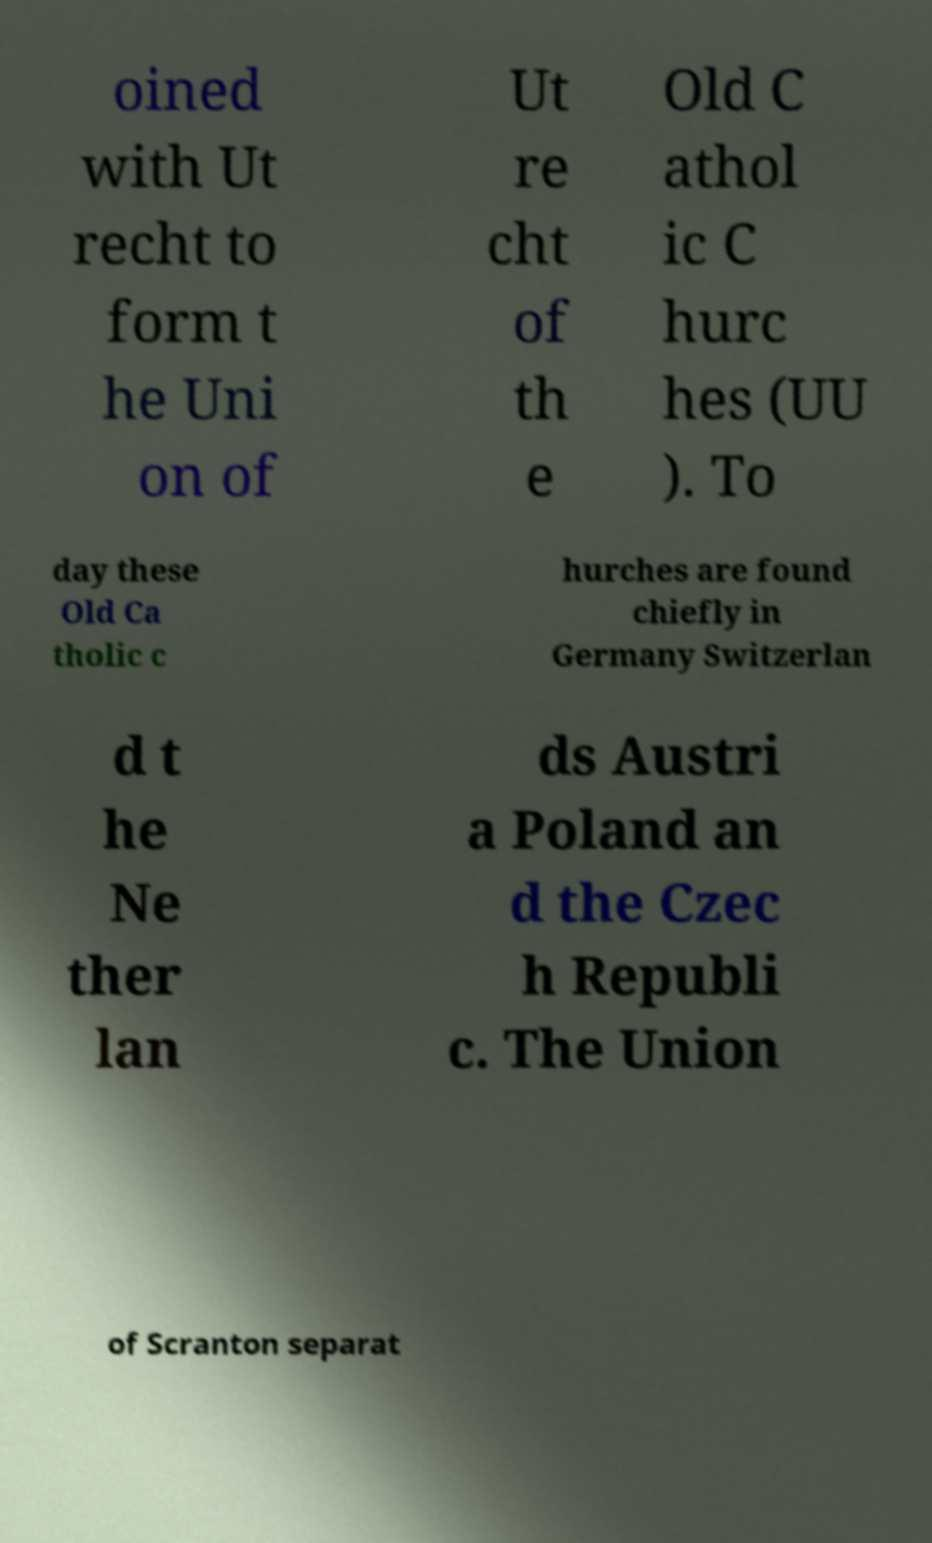What messages or text are displayed in this image? I need them in a readable, typed format. oined with Ut recht to form t he Uni on of Ut re cht of th e Old C athol ic C hurc hes (UU ). To day these Old Ca tholic c hurches are found chiefly in Germany Switzerlan d t he Ne ther lan ds Austri a Poland an d the Czec h Republi c. The Union of Scranton separat 